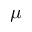<formula> <loc_0><loc_0><loc_500><loc_500>\mu</formula> 